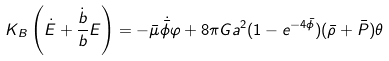<formula> <loc_0><loc_0><loc_500><loc_500>K _ { B } \left ( \dot { E } + \frac { \dot { b } } { b } E \right ) = - \bar { \mu } \dot { \bar { \phi } } \varphi + 8 \pi G a ^ { 2 } ( 1 - e ^ { - 4 \bar { \phi } } ) ( \bar { \rho } + \bar { P } ) \theta</formula> 